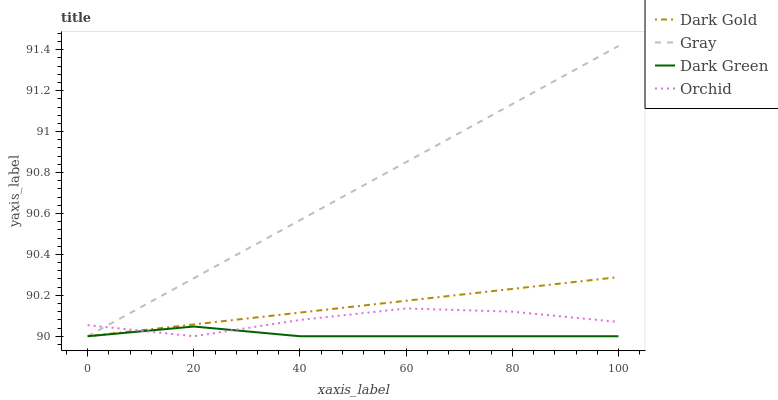Does Dark Green have the minimum area under the curve?
Answer yes or no. Yes. Does Gray have the maximum area under the curve?
Answer yes or no. Yes. Does Gray have the minimum area under the curve?
Answer yes or no. No. Does Dark Green have the maximum area under the curve?
Answer yes or no. No. Is Gray the smoothest?
Answer yes or no. Yes. Is Orchid the roughest?
Answer yes or no. Yes. Is Dark Green the smoothest?
Answer yes or no. No. Is Dark Green the roughest?
Answer yes or no. No. Does Orchid have the lowest value?
Answer yes or no. Yes. Does Gray have the highest value?
Answer yes or no. Yes. Does Dark Green have the highest value?
Answer yes or no. No. Does Dark Green intersect Dark Gold?
Answer yes or no. Yes. Is Dark Green less than Dark Gold?
Answer yes or no. No. Is Dark Green greater than Dark Gold?
Answer yes or no. No. 